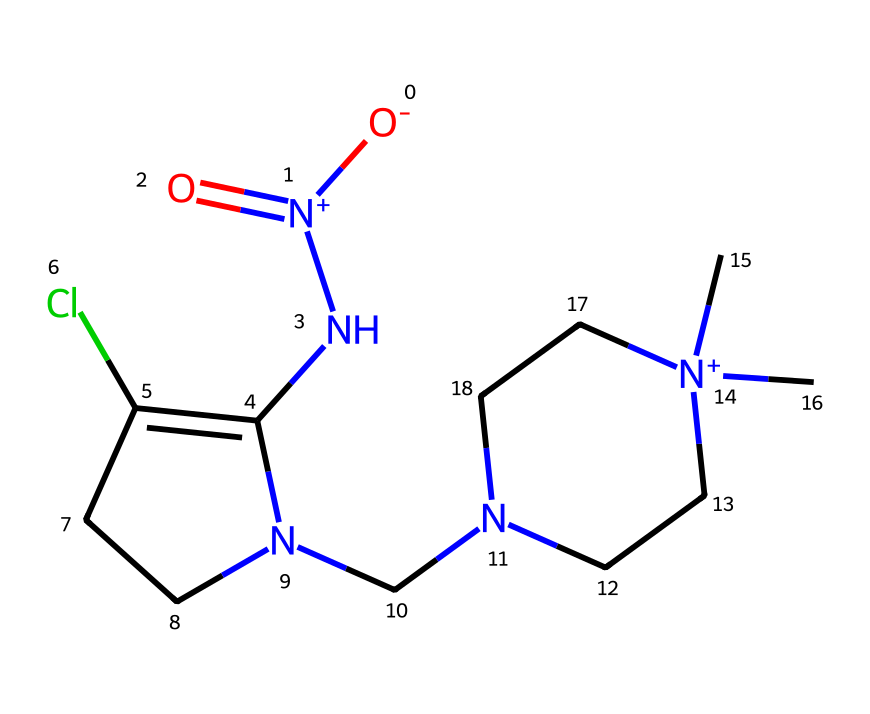What is the total number of nitrogen atoms in imidacloprid? The SMILES representation shows two nitrogen atoms represented by 'N' and 'N+' in the structure. Counting these gives a total of two nitrogen atoms.
Answer: two How many chlorine atoms are present in the molecule? In the given SMILES string, 'Cl' indicates the presence of one chlorine atom. Therefore, there is a total of one chlorine atom in the molecule.
Answer: one What type of functional group is indicated by "O=N(=O)"? The "O=N(=O)" part of the molecule indicates a nitro functional group, as it contains a nitrogen atom bonded to two oxygen atoms, revealing its characteristic structure.
Answer: nitro Identify the atom that carries a positive charge in the structure. The notation "[N+]" in the SMILES indicates that the nitrogen atom adjacent to the two carbon atoms is positively charged. Thus, this nitrogen atom is the one carrying the positive charge.
Answer: nitrogen How many cyclic structures are present in the molecule? There are two rings in the structure, indicated by the presence of the number '1' and '2' in the SMILES, which are part of the cyclic ring systems in the molecule.
Answer: two Is imidacloprid a polar or nonpolar molecule? Considering the presence of polar functional groups such as nitro groups and nitrogen atoms, along with hydrophilic regions, imidacloprid can be classified as a polar molecule overall.
Answer: polar What is the primary application of imidacloprid? Imidacloprid is primarily used as an insecticide, particularly against a wide range of pests in agricultural and horticultural applications.
Answer: insecticide 